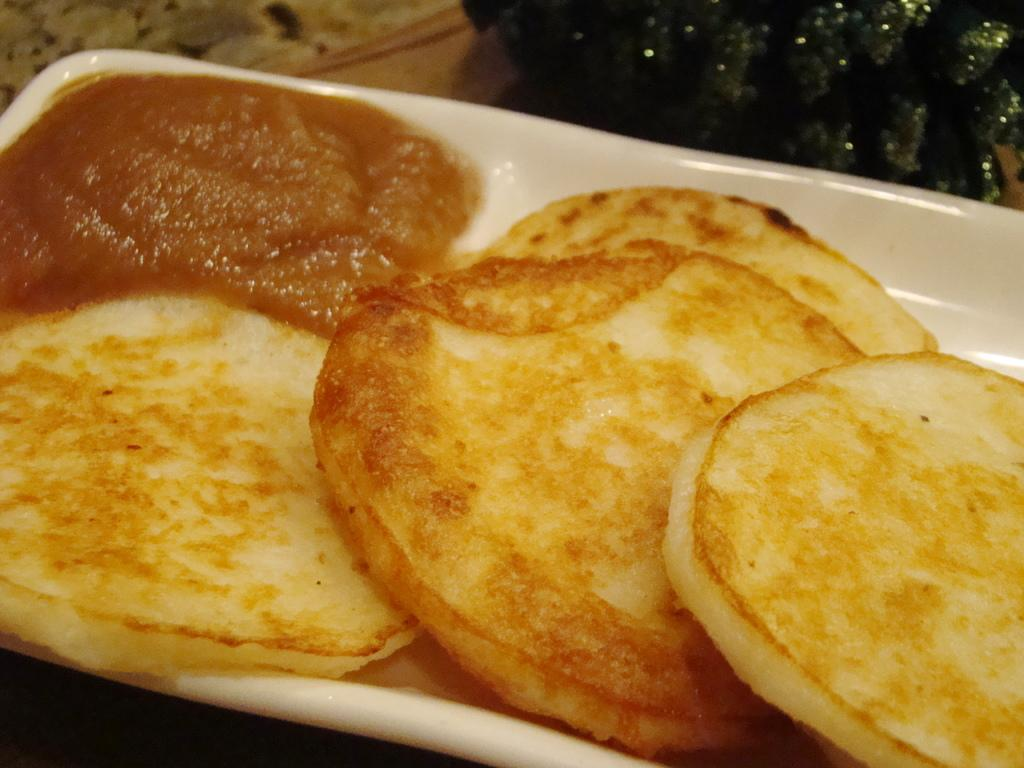What is on the plate that is visible in the image? The plate contains food items. What color is the cloth in the image? The cloth in the image is green. How many ducks are sitting on the plate in the image? There are no ducks present on the plate or in the image. What type of angle is depicted in the image? There is no angle depicted in the image; it features a plate with food items and a green cloth. 